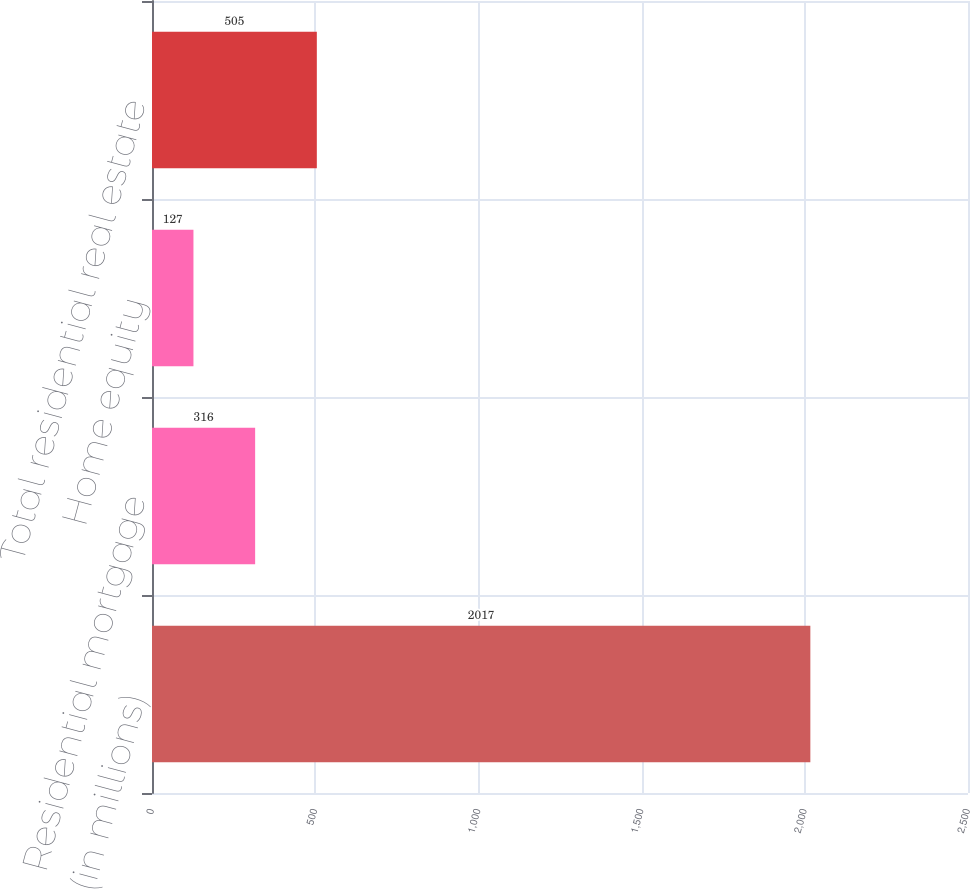Convert chart. <chart><loc_0><loc_0><loc_500><loc_500><bar_chart><fcel>(in millions)<fcel>Residential mortgage<fcel>Home equity<fcel>Total residential real estate<nl><fcel>2017<fcel>316<fcel>127<fcel>505<nl></chart> 